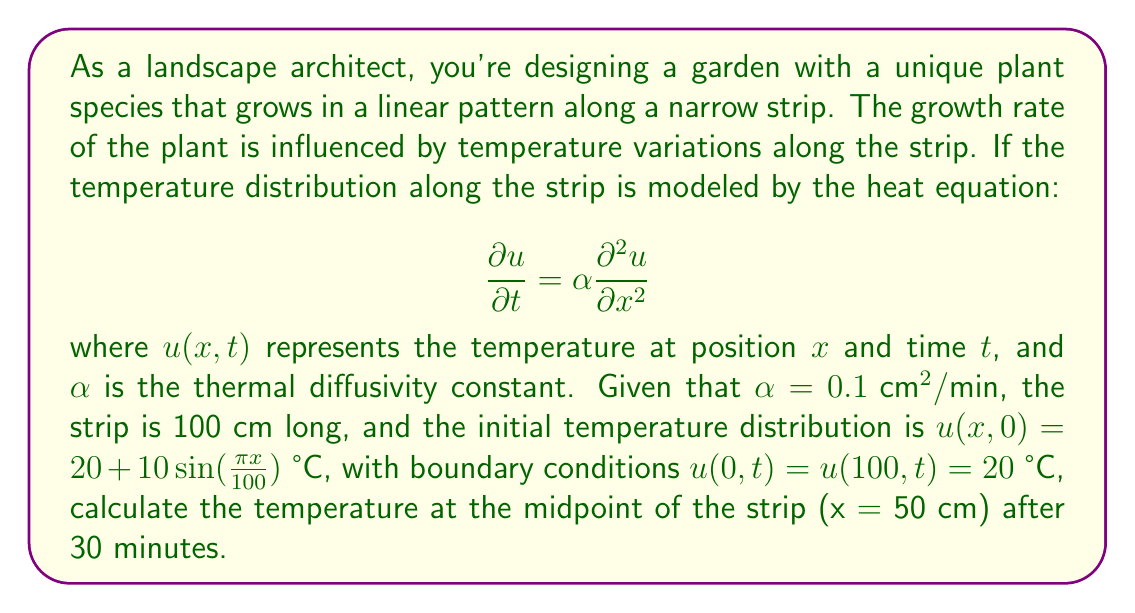What is the answer to this math problem? To solve this problem, we need to use the solution to the heat equation with the given initial and boundary conditions. The general solution for this type of problem is given by the Fourier series:

$$u(x,t) = 20 + \sum_{n=1}^{\infty} B_n \sin(\frac{n\pi x}{L}) e^{-\alpha (\frac{n\pi}{L})^2 t}$$

where $L$ is the length of the strip (100 cm in this case).

Step 1: Determine the coefficient $B_n$
Given the initial condition $u(x,0) = 20 + 10 \sin(\frac{\pi x}{100})$, we can see that only the first term of the series ($n=1$) is non-zero, and $B_1 = 10$.

Step 2: Simplify the solution
Our solution becomes:

$$u(x,t) = 20 + 10 \sin(\frac{\pi x}{100}) e^{-0.1 (\frac{\pi}{100})^2 t}$$

Step 3: Calculate the temperature at x = 50 cm and t = 30 min
Substituting the values:

$$\begin{align*}
u(50,30) &= 20 + 10 \sin(\frac{\pi \cdot 50}{100}) e^{-0.1 (\frac{\pi}{100})^2 \cdot 30} \\
&= 20 + 10 \sin(\frac{\pi}{2}) e^{-0.1 (\frac{\pi}{100})^2 \cdot 30} \\
&= 20 + 10 \cdot 1 \cdot e^{-0.0002827 \cdot 30} \\
&= 20 + 10 \cdot e^{-0.008481} \\
&= 20 + 10 \cdot 0.9916 \\
&= 20 + 9.916 \\
&= 29.916 \text{ °C}
\end{align*}$$
Answer: The temperature at the midpoint of the strip (x = 50 cm) after 30 minutes is approximately 29.92 °C. 